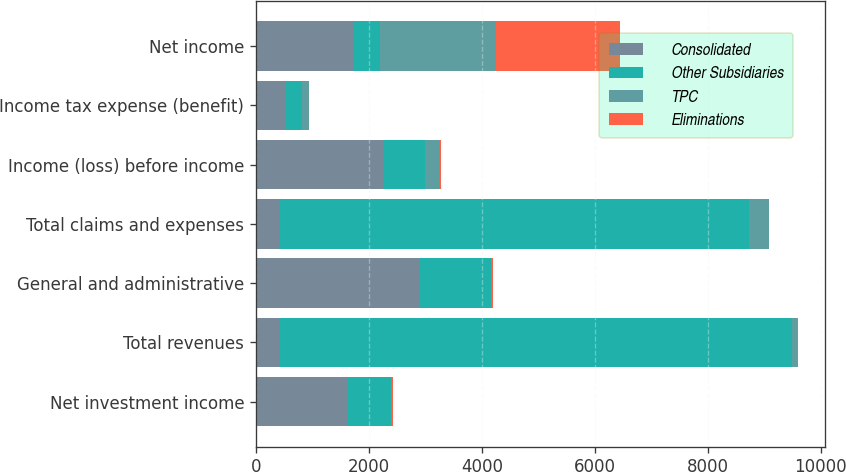<chart> <loc_0><loc_0><loc_500><loc_500><stacked_bar_chart><ecel><fcel>Net investment income<fcel>Total revenues<fcel>General and administrative<fcel>Total claims and expenses<fcel>Income (loss) before income<fcel>Income tax expense (benefit)<fcel>Net income<nl><fcel>Consolidated<fcel>1627<fcel>404<fcel>2906<fcel>404<fcel>2247<fcel>519<fcel>1728<nl><fcel>Other Subsidiaries<fcel>759<fcel>9079<fcel>1249<fcel>8327<fcel>752<fcel>290<fcel>462<nl><fcel>TPC<fcel>24<fcel>90<fcel>25<fcel>346<fcel>256<fcel>130<fcel>2064<nl><fcel>Eliminations<fcel>13<fcel>23<fcel>10<fcel>10<fcel>13<fcel>5<fcel>2198<nl></chart> 